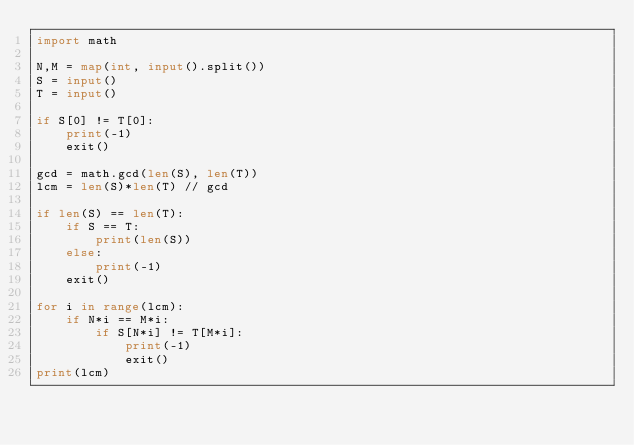<code> <loc_0><loc_0><loc_500><loc_500><_Python_>import math

N,M = map(int, input().split())
S = input()
T = input()

if S[0] != T[0]:
    print(-1)
    exit()

gcd = math.gcd(len(S), len(T))
lcm = len(S)*len(T) // gcd

if len(S) == len(T):
    if S == T:
        print(len(S))
    else:
        print(-1)
    exit()

for i in range(lcm):
    if N*i == M*i:
        if S[N*i] != T[M*i]:
            print(-1)
            exit()
print(lcm)
</code> 